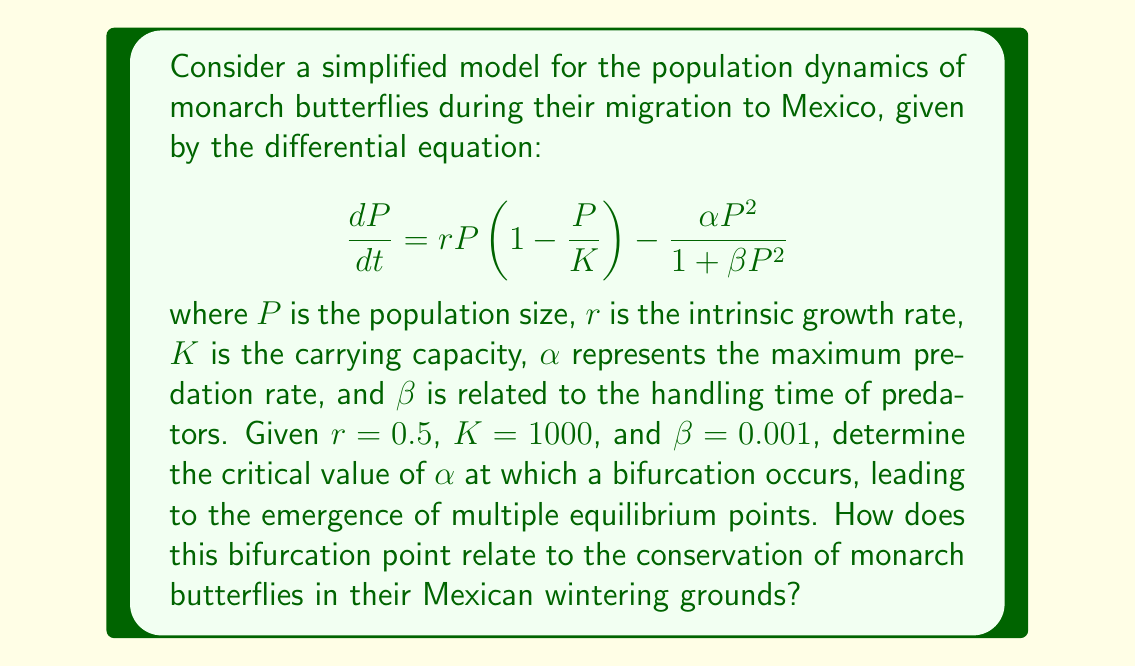Teach me how to tackle this problem. To solve this problem, we'll use bifurcation theory to analyze the equilibrium points of the system:

1) First, we find the equilibrium points by setting $\frac{dP}{dt} = 0$:

   $$0 = rP(1 - \frac{P}{K}) - \frac{\alpha P^2}{1 + \beta P^2}$$

2) Rearrange the equation:

   $$rP(1 - \frac{P}{K})(1 + \beta P^2) = \alpha P^2$$

3) Expand and simplify:

   $$r(1 + \beta P^2) - \frac{r}{K}P(1 + \beta P^2) = \alpha P$$

4) To find the bifurcation point, we need to find when the system changes from one to multiple equilibrium points. This occurs when the equation has a double root, which happens when the derivative of both sides with respect to $P$ is equal:

   $$\frac{d}{dP}[r(1 + \beta P^2) - \frac{r}{K}P(1 + \beta P^2)] = \frac{d}{dP}[\alpha P]$$

5) Simplify:

   $$2r\beta P - \frac{r}{K}(1 + 3\beta P^2) = \alpha$$

6) At the bifurcation point, this equation should have a double root. This occurs when the discriminant of the quadratic equation in $P$ is zero. The discriminant is given by $b^2 - 4ac$ where $a$, $b$, and $c$ are the coefficients of the quadratic equation.

7) Rearranging the equation into standard quadratic form:

   $$3r\beta P^2 - 2r\beta KP + (r - \alpha K) = 0$$

8) The discriminant is:

   $$(2r\beta K)^2 - 4(3r\beta)(r - \alpha K) = 0$$

9) Solve for $\alpha$:

   $$\alpha_{critical} = \frac{r}{K} + \frac{r\beta K}{3}$$

10) Substitute the given values:

    $$\alpha_{critical} = \frac{0.5}{1000} + \frac{0.5 * 0.001 * 1000}{3} = 0.1670$$

This critical value of $\alpha$ represents the point at which the system transitions from having a single stable equilibrium to having multiple equilibria. In the context of monarch butterfly conservation in Mexico, this bifurcation point signifies a threshold in predation pressure. Below this threshold, the population has a single stable state, while above it, alternative stable states can exist, potentially leading to sudden population collapses if the system is perturbed. Understanding this threshold is crucial for implementing effective conservation strategies in the Mexican wintering grounds.
Answer: $\alpha_{critical} = 0.1670$ 